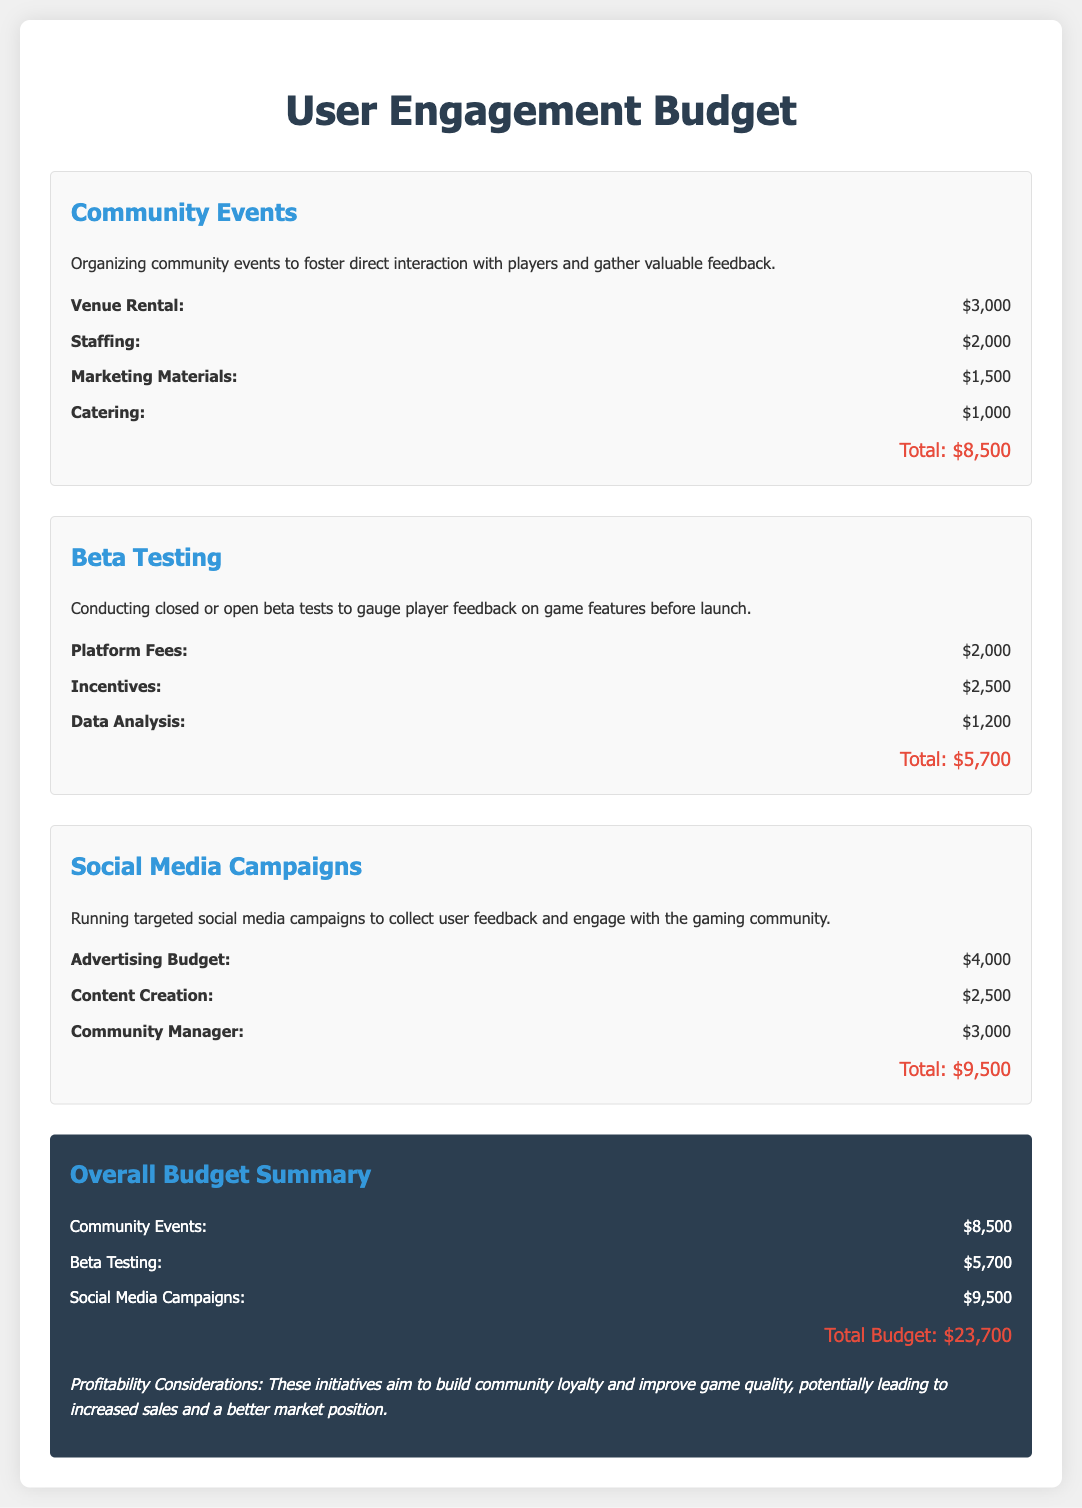What is the total cost for Community Events? The total cost for Community Events is provided in the document under the relevant section, amounting to $8,500.
Answer: $8,500 What is the cost for incentives in Beta Testing? The cost for incentives in the Beta Testing section is specifically listed as $2,500.
Answer: $2,500 What is the advertising budget for Social Media Campaigns? The advertising budget is mentioned in the Social Media Campaigns section, totaling $4,000.
Answer: $4,000 What is the total budget for all initiatives? The total budget is provided in the summary section, representing the sum of all costs, which amounts to $23,700.
Answer: $23,700 Which user engagement initiative has the highest cost? By comparing the total costs of all initiatives listed, Social Media Campaigns have the highest cost of $9,500.
Answer: Social Media Campaigns What is the total amount spent on data analysis for Beta Testing? The total amount spent on data analysis for Beta Testing is detailed in the respective section, amounting to $1,200.
Answer: $1,200 What is the total cost of staffing for Community Events? The total cost of staffing is outlined in the Community Events section and is listed as $2,000.
Answer: $2,000 Is catering included in the Beta Testing costs? Catering is not mentioned in the Beta Testing section; it is part of the Community Events costs instead.
Answer: No How does the budget contribute to profitability? The document highlights that these initiatives aim to build community loyalty and improve game quality, which can lead to increased sales.
Answer: Increased sales 